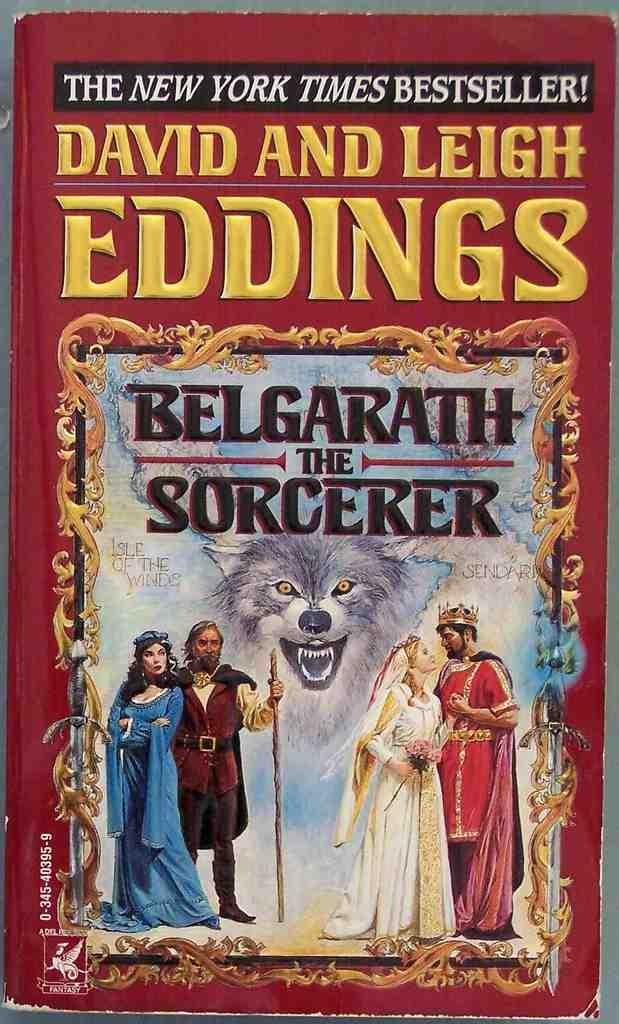<image>
Give a short and clear explanation of the subsequent image. A book that is on the New York Times Bestseller list that is titledBelgarath The Sorcer. 